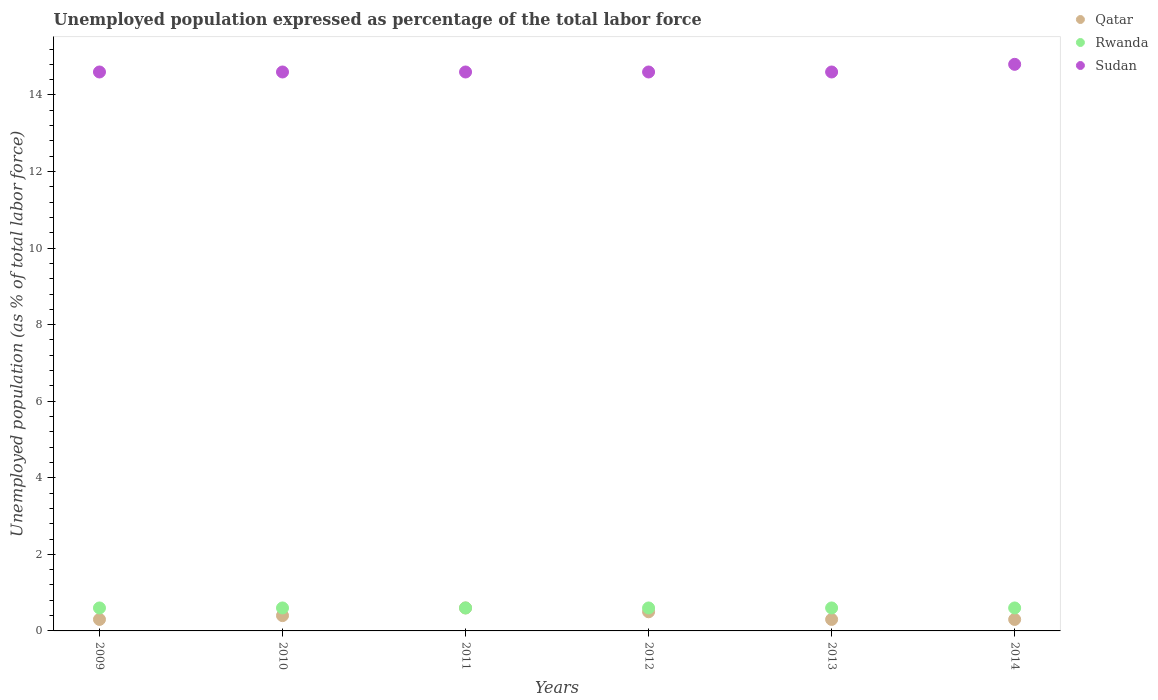How many different coloured dotlines are there?
Your answer should be very brief. 3. What is the unemployment in in Rwanda in 2009?
Offer a very short reply. 0.6. Across all years, what is the maximum unemployment in in Sudan?
Make the answer very short. 14.8. Across all years, what is the minimum unemployment in in Rwanda?
Keep it short and to the point. 0.6. What is the total unemployment in in Qatar in the graph?
Provide a succinct answer. 2.4. What is the difference between the unemployment in in Rwanda in 2011 and that in 2014?
Your response must be concise. 0. What is the difference between the unemployment in in Rwanda in 2014 and the unemployment in in Qatar in 2010?
Your response must be concise. 0.2. What is the average unemployment in in Qatar per year?
Ensure brevity in your answer.  0.4. In the year 2009, what is the difference between the unemployment in in Qatar and unemployment in in Sudan?
Keep it short and to the point. -14.3. What is the ratio of the unemployment in in Sudan in 2010 to that in 2014?
Provide a short and direct response. 0.99. Is the unemployment in in Sudan in 2009 less than that in 2012?
Offer a very short reply. No. Is the difference between the unemployment in in Qatar in 2009 and 2013 greater than the difference between the unemployment in in Sudan in 2009 and 2013?
Your answer should be very brief. No. What is the difference between the highest and the second highest unemployment in in Sudan?
Keep it short and to the point. 0.2. What is the difference between the highest and the lowest unemployment in in Rwanda?
Provide a succinct answer. 0. In how many years, is the unemployment in in Sudan greater than the average unemployment in in Sudan taken over all years?
Offer a very short reply. 1. Is the unemployment in in Qatar strictly less than the unemployment in in Rwanda over the years?
Make the answer very short. No. How many dotlines are there?
Keep it short and to the point. 3. How many years are there in the graph?
Provide a succinct answer. 6. What is the difference between two consecutive major ticks on the Y-axis?
Your response must be concise. 2. How many legend labels are there?
Give a very brief answer. 3. How are the legend labels stacked?
Provide a succinct answer. Vertical. What is the title of the graph?
Keep it short and to the point. Unemployed population expressed as percentage of the total labor force. What is the label or title of the Y-axis?
Provide a short and direct response. Unemployed population (as % of total labor force). What is the Unemployed population (as % of total labor force) in Qatar in 2009?
Provide a short and direct response. 0.3. What is the Unemployed population (as % of total labor force) of Rwanda in 2009?
Your response must be concise. 0.6. What is the Unemployed population (as % of total labor force) in Sudan in 2009?
Ensure brevity in your answer.  14.6. What is the Unemployed population (as % of total labor force) of Qatar in 2010?
Provide a short and direct response. 0.4. What is the Unemployed population (as % of total labor force) in Rwanda in 2010?
Provide a short and direct response. 0.6. What is the Unemployed population (as % of total labor force) in Sudan in 2010?
Make the answer very short. 14.6. What is the Unemployed population (as % of total labor force) of Qatar in 2011?
Your answer should be very brief. 0.6. What is the Unemployed population (as % of total labor force) in Rwanda in 2011?
Offer a very short reply. 0.6. What is the Unemployed population (as % of total labor force) of Sudan in 2011?
Your answer should be very brief. 14.6. What is the Unemployed population (as % of total labor force) in Rwanda in 2012?
Ensure brevity in your answer.  0.6. What is the Unemployed population (as % of total labor force) of Sudan in 2012?
Give a very brief answer. 14.6. What is the Unemployed population (as % of total labor force) of Qatar in 2013?
Make the answer very short. 0.3. What is the Unemployed population (as % of total labor force) of Rwanda in 2013?
Offer a very short reply. 0.6. What is the Unemployed population (as % of total labor force) of Sudan in 2013?
Offer a very short reply. 14.6. What is the Unemployed population (as % of total labor force) in Qatar in 2014?
Give a very brief answer. 0.3. What is the Unemployed population (as % of total labor force) of Rwanda in 2014?
Your answer should be compact. 0.6. What is the Unemployed population (as % of total labor force) in Sudan in 2014?
Your answer should be compact. 14.8. Across all years, what is the maximum Unemployed population (as % of total labor force) of Qatar?
Your response must be concise. 0.6. Across all years, what is the maximum Unemployed population (as % of total labor force) of Rwanda?
Give a very brief answer. 0.6. Across all years, what is the maximum Unemployed population (as % of total labor force) of Sudan?
Your response must be concise. 14.8. Across all years, what is the minimum Unemployed population (as % of total labor force) in Qatar?
Your answer should be compact. 0.3. Across all years, what is the minimum Unemployed population (as % of total labor force) in Rwanda?
Your answer should be compact. 0.6. Across all years, what is the minimum Unemployed population (as % of total labor force) in Sudan?
Your answer should be very brief. 14.6. What is the total Unemployed population (as % of total labor force) in Rwanda in the graph?
Your answer should be very brief. 3.6. What is the total Unemployed population (as % of total labor force) in Sudan in the graph?
Ensure brevity in your answer.  87.8. What is the difference between the Unemployed population (as % of total labor force) in Qatar in 2009 and that in 2010?
Offer a very short reply. -0.1. What is the difference between the Unemployed population (as % of total labor force) of Rwanda in 2009 and that in 2010?
Your response must be concise. 0. What is the difference between the Unemployed population (as % of total labor force) of Rwanda in 2009 and that in 2011?
Keep it short and to the point. 0. What is the difference between the Unemployed population (as % of total labor force) in Sudan in 2009 and that in 2011?
Keep it short and to the point. 0. What is the difference between the Unemployed population (as % of total labor force) in Rwanda in 2009 and that in 2012?
Provide a succinct answer. 0. What is the difference between the Unemployed population (as % of total labor force) of Qatar in 2010 and that in 2011?
Keep it short and to the point. -0.2. What is the difference between the Unemployed population (as % of total labor force) in Rwanda in 2010 and that in 2011?
Your answer should be very brief. 0. What is the difference between the Unemployed population (as % of total labor force) of Sudan in 2010 and that in 2012?
Your answer should be very brief. 0. What is the difference between the Unemployed population (as % of total labor force) in Qatar in 2010 and that in 2013?
Offer a very short reply. 0.1. What is the difference between the Unemployed population (as % of total labor force) in Rwanda in 2010 and that in 2013?
Make the answer very short. 0. What is the difference between the Unemployed population (as % of total labor force) in Sudan in 2010 and that in 2013?
Your answer should be compact. 0. What is the difference between the Unemployed population (as % of total labor force) of Sudan in 2010 and that in 2014?
Your answer should be very brief. -0.2. What is the difference between the Unemployed population (as % of total labor force) in Sudan in 2011 and that in 2012?
Make the answer very short. 0. What is the difference between the Unemployed population (as % of total labor force) in Qatar in 2011 and that in 2013?
Your answer should be compact. 0.3. What is the difference between the Unemployed population (as % of total labor force) of Rwanda in 2011 and that in 2013?
Your answer should be very brief. 0. What is the difference between the Unemployed population (as % of total labor force) in Rwanda in 2011 and that in 2014?
Keep it short and to the point. 0. What is the difference between the Unemployed population (as % of total labor force) of Sudan in 2011 and that in 2014?
Provide a short and direct response. -0.2. What is the difference between the Unemployed population (as % of total labor force) of Sudan in 2012 and that in 2013?
Your response must be concise. 0. What is the difference between the Unemployed population (as % of total labor force) of Rwanda in 2012 and that in 2014?
Ensure brevity in your answer.  0. What is the difference between the Unemployed population (as % of total labor force) in Qatar in 2013 and that in 2014?
Offer a very short reply. 0. What is the difference between the Unemployed population (as % of total labor force) in Qatar in 2009 and the Unemployed population (as % of total labor force) in Sudan in 2010?
Your answer should be compact. -14.3. What is the difference between the Unemployed population (as % of total labor force) in Rwanda in 2009 and the Unemployed population (as % of total labor force) in Sudan in 2010?
Provide a succinct answer. -14. What is the difference between the Unemployed population (as % of total labor force) in Qatar in 2009 and the Unemployed population (as % of total labor force) in Rwanda in 2011?
Provide a short and direct response. -0.3. What is the difference between the Unemployed population (as % of total labor force) in Qatar in 2009 and the Unemployed population (as % of total labor force) in Sudan in 2011?
Your response must be concise. -14.3. What is the difference between the Unemployed population (as % of total labor force) of Qatar in 2009 and the Unemployed population (as % of total labor force) of Rwanda in 2012?
Make the answer very short. -0.3. What is the difference between the Unemployed population (as % of total labor force) in Qatar in 2009 and the Unemployed population (as % of total labor force) in Sudan in 2012?
Give a very brief answer. -14.3. What is the difference between the Unemployed population (as % of total labor force) in Rwanda in 2009 and the Unemployed population (as % of total labor force) in Sudan in 2012?
Make the answer very short. -14. What is the difference between the Unemployed population (as % of total labor force) in Qatar in 2009 and the Unemployed population (as % of total labor force) in Rwanda in 2013?
Offer a terse response. -0.3. What is the difference between the Unemployed population (as % of total labor force) of Qatar in 2009 and the Unemployed population (as % of total labor force) of Sudan in 2013?
Your response must be concise. -14.3. What is the difference between the Unemployed population (as % of total labor force) in Rwanda in 2009 and the Unemployed population (as % of total labor force) in Sudan in 2013?
Offer a terse response. -14. What is the difference between the Unemployed population (as % of total labor force) in Qatar in 2009 and the Unemployed population (as % of total labor force) in Sudan in 2014?
Your response must be concise. -14.5. What is the difference between the Unemployed population (as % of total labor force) in Rwanda in 2009 and the Unemployed population (as % of total labor force) in Sudan in 2014?
Offer a terse response. -14.2. What is the difference between the Unemployed population (as % of total labor force) of Qatar in 2010 and the Unemployed population (as % of total labor force) of Rwanda in 2011?
Ensure brevity in your answer.  -0.2. What is the difference between the Unemployed population (as % of total labor force) in Rwanda in 2010 and the Unemployed population (as % of total labor force) in Sudan in 2011?
Provide a succinct answer. -14. What is the difference between the Unemployed population (as % of total labor force) in Qatar in 2010 and the Unemployed population (as % of total labor force) in Sudan in 2012?
Give a very brief answer. -14.2. What is the difference between the Unemployed population (as % of total labor force) of Qatar in 2010 and the Unemployed population (as % of total labor force) of Sudan in 2013?
Give a very brief answer. -14.2. What is the difference between the Unemployed population (as % of total labor force) of Qatar in 2010 and the Unemployed population (as % of total labor force) of Sudan in 2014?
Offer a very short reply. -14.4. What is the difference between the Unemployed population (as % of total labor force) in Qatar in 2011 and the Unemployed population (as % of total labor force) in Rwanda in 2012?
Ensure brevity in your answer.  0. What is the difference between the Unemployed population (as % of total labor force) of Qatar in 2011 and the Unemployed population (as % of total labor force) of Sudan in 2013?
Offer a very short reply. -14. What is the difference between the Unemployed population (as % of total labor force) in Qatar in 2011 and the Unemployed population (as % of total labor force) in Rwanda in 2014?
Your answer should be compact. 0. What is the difference between the Unemployed population (as % of total labor force) in Qatar in 2011 and the Unemployed population (as % of total labor force) in Sudan in 2014?
Give a very brief answer. -14.2. What is the difference between the Unemployed population (as % of total labor force) of Qatar in 2012 and the Unemployed population (as % of total labor force) of Rwanda in 2013?
Your answer should be compact. -0.1. What is the difference between the Unemployed population (as % of total labor force) of Qatar in 2012 and the Unemployed population (as % of total labor force) of Sudan in 2013?
Make the answer very short. -14.1. What is the difference between the Unemployed population (as % of total labor force) of Rwanda in 2012 and the Unemployed population (as % of total labor force) of Sudan in 2013?
Offer a very short reply. -14. What is the difference between the Unemployed population (as % of total labor force) in Qatar in 2012 and the Unemployed population (as % of total labor force) in Rwanda in 2014?
Keep it short and to the point. -0.1. What is the difference between the Unemployed population (as % of total labor force) of Qatar in 2012 and the Unemployed population (as % of total labor force) of Sudan in 2014?
Your answer should be very brief. -14.3. What is the difference between the Unemployed population (as % of total labor force) in Rwanda in 2012 and the Unemployed population (as % of total labor force) in Sudan in 2014?
Ensure brevity in your answer.  -14.2. What is the difference between the Unemployed population (as % of total labor force) in Rwanda in 2013 and the Unemployed population (as % of total labor force) in Sudan in 2014?
Your response must be concise. -14.2. What is the average Unemployed population (as % of total labor force) of Sudan per year?
Ensure brevity in your answer.  14.63. In the year 2009, what is the difference between the Unemployed population (as % of total labor force) in Qatar and Unemployed population (as % of total labor force) in Sudan?
Provide a succinct answer. -14.3. In the year 2010, what is the difference between the Unemployed population (as % of total labor force) of Qatar and Unemployed population (as % of total labor force) of Rwanda?
Provide a short and direct response. -0.2. In the year 2010, what is the difference between the Unemployed population (as % of total labor force) in Qatar and Unemployed population (as % of total labor force) in Sudan?
Give a very brief answer. -14.2. In the year 2011, what is the difference between the Unemployed population (as % of total labor force) of Qatar and Unemployed population (as % of total labor force) of Sudan?
Provide a succinct answer. -14. In the year 2011, what is the difference between the Unemployed population (as % of total labor force) in Rwanda and Unemployed population (as % of total labor force) in Sudan?
Offer a terse response. -14. In the year 2012, what is the difference between the Unemployed population (as % of total labor force) of Qatar and Unemployed population (as % of total labor force) of Sudan?
Provide a short and direct response. -14.1. In the year 2012, what is the difference between the Unemployed population (as % of total labor force) of Rwanda and Unemployed population (as % of total labor force) of Sudan?
Your answer should be compact. -14. In the year 2013, what is the difference between the Unemployed population (as % of total labor force) in Qatar and Unemployed population (as % of total labor force) in Sudan?
Ensure brevity in your answer.  -14.3. In the year 2013, what is the difference between the Unemployed population (as % of total labor force) of Rwanda and Unemployed population (as % of total labor force) of Sudan?
Offer a terse response. -14. In the year 2014, what is the difference between the Unemployed population (as % of total labor force) of Qatar and Unemployed population (as % of total labor force) of Sudan?
Your answer should be very brief. -14.5. What is the ratio of the Unemployed population (as % of total labor force) of Qatar in 2009 to that in 2010?
Your response must be concise. 0.75. What is the ratio of the Unemployed population (as % of total labor force) in Rwanda in 2009 to that in 2010?
Make the answer very short. 1. What is the ratio of the Unemployed population (as % of total labor force) in Qatar in 2009 to that in 2013?
Make the answer very short. 1. What is the ratio of the Unemployed population (as % of total labor force) of Qatar in 2009 to that in 2014?
Make the answer very short. 1. What is the ratio of the Unemployed population (as % of total labor force) in Rwanda in 2009 to that in 2014?
Provide a short and direct response. 1. What is the ratio of the Unemployed population (as % of total labor force) of Sudan in 2009 to that in 2014?
Offer a terse response. 0.99. What is the ratio of the Unemployed population (as % of total labor force) of Rwanda in 2010 to that in 2011?
Provide a succinct answer. 1. What is the ratio of the Unemployed population (as % of total labor force) in Qatar in 2010 to that in 2012?
Give a very brief answer. 0.8. What is the ratio of the Unemployed population (as % of total labor force) in Qatar in 2010 to that in 2013?
Keep it short and to the point. 1.33. What is the ratio of the Unemployed population (as % of total labor force) of Sudan in 2010 to that in 2013?
Ensure brevity in your answer.  1. What is the ratio of the Unemployed population (as % of total labor force) in Rwanda in 2010 to that in 2014?
Ensure brevity in your answer.  1. What is the ratio of the Unemployed population (as % of total labor force) of Sudan in 2010 to that in 2014?
Give a very brief answer. 0.99. What is the ratio of the Unemployed population (as % of total labor force) of Qatar in 2011 to that in 2012?
Provide a short and direct response. 1.2. What is the ratio of the Unemployed population (as % of total labor force) of Sudan in 2011 to that in 2012?
Your answer should be very brief. 1. What is the ratio of the Unemployed population (as % of total labor force) of Qatar in 2011 to that in 2013?
Offer a very short reply. 2. What is the ratio of the Unemployed population (as % of total labor force) in Rwanda in 2011 to that in 2013?
Your response must be concise. 1. What is the ratio of the Unemployed population (as % of total labor force) of Qatar in 2011 to that in 2014?
Provide a succinct answer. 2. What is the ratio of the Unemployed population (as % of total labor force) in Rwanda in 2011 to that in 2014?
Offer a terse response. 1. What is the ratio of the Unemployed population (as % of total labor force) of Sudan in 2011 to that in 2014?
Your answer should be very brief. 0.99. What is the ratio of the Unemployed population (as % of total labor force) in Qatar in 2012 to that in 2013?
Keep it short and to the point. 1.67. What is the ratio of the Unemployed population (as % of total labor force) in Sudan in 2012 to that in 2013?
Keep it short and to the point. 1. What is the ratio of the Unemployed population (as % of total labor force) of Sudan in 2012 to that in 2014?
Offer a terse response. 0.99. What is the ratio of the Unemployed population (as % of total labor force) of Qatar in 2013 to that in 2014?
Provide a succinct answer. 1. What is the ratio of the Unemployed population (as % of total labor force) of Rwanda in 2013 to that in 2014?
Offer a very short reply. 1. What is the ratio of the Unemployed population (as % of total labor force) of Sudan in 2013 to that in 2014?
Your answer should be very brief. 0.99. What is the difference between the highest and the second highest Unemployed population (as % of total labor force) in Rwanda?
Give a very brief answer. 0. What is the difference between the highest and the lowest Unemployed population (as % of total labor force) of Qatar?
Your response must be concise. 0.3. What is the difference between the highest and the lowest Unemployed population (as % of total labor force) in Rwanda?
Offer a very short reply. 0. What is the difference between the highest and the lowest Unemployed population (as % of total labor force) in Sudan?
Give a very brief answer. 0.2. 